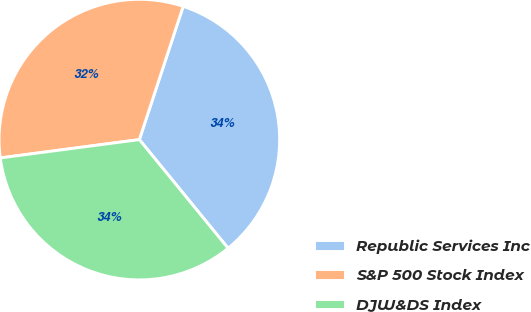Convert chart to OTSL. <chart><loc_0><loc_0><loc_500><loc_500><pie_chart><fcel>Republic Services Inc<fcel>S&P 500 Stock Index<fcel>DJW&DS Index<nl><fcel>34.04%<fcel>32.14%<fcel>33.81%<nl></chart> 